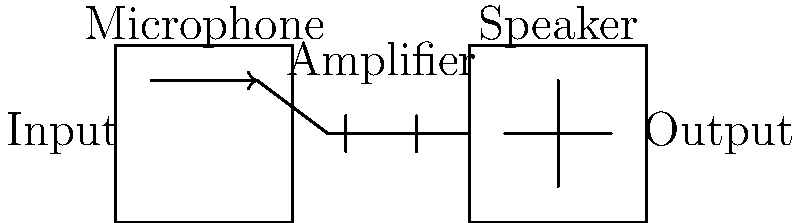In the basic public address system used in mid-20th century football stadiums, what was the primary function of the amplifier in the circuit design, and how did it contribute to the overall system performance? To understand the function of the amplifier in a mid-20th century public address system for football stadiums, let's break down the circuit design:

1. Input Stage (Microphone):
   - The microphone converts sound waves (voice or audio) into weak electrical signals.
   - These signals are typically in the range of millivolts (mV).

2. Amplification Stage:
   - The weak electrical signals from the microphone are sent to the amplifier.
   - The amplifier's primary function is to increase the amplitude of these signals.
   - It does this by providing voltage gain, typically expressed as:
     $$ A_v = \frac{V_{out}}{V_{in}} $$
   where $A_v$ is the voltage gain, $V_{out}$ is the output voltage, and $V_{in}$ is the input voltage.

3. Output Stage (Speaker):
   - The amplified signals are then sent to the speaker.
   - The speaker converts these electrical signals back into sound waves, but at a much higher volume than the original input.

The amplifier contributes to the overall system performance in several ways:

a) Increased Volume: By amplifying the signal, it allows the sound to be heard clearly throughout the stadium.

b) Impedance Matching: It often provides proper impedance matching between the low-impedance microphone and the higher-impedance speaker, ensuring efficient power transfer.

c) Frequency Response: Mid-20th century amplifiers could be designed to emphasize certain frequencies, potentially improving voice clarity in noisy stadium environments.

d) Power Output: The amplifier provides the necessary power to drive large stadium speakers, typically measured in watts (W).

In the context of mid-20th century technology, these amplifiers were likely based on vacuum tube designs, which could provide high power output and were robust enough for outdoor use in varying weather conditions.
Answer: To increase signal amplitude, enabling stadium-wide sound projection 